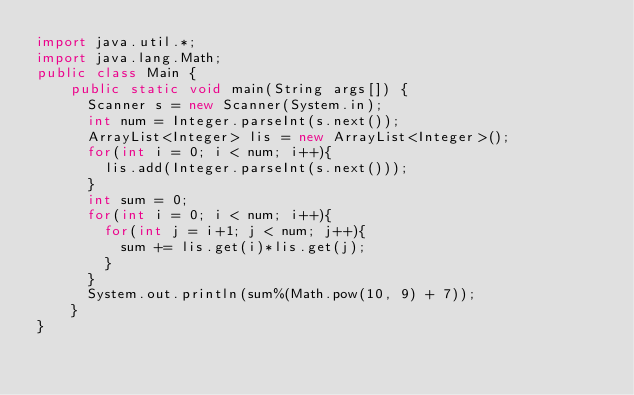<code> <loc_0><loc_0><loc_500><loc_500><_Java_>import java.util.*;
import java.lang.Math;
public class Main {
    public static void main(String args[]) {
      Scanner s = new Scanner(System.in);
      int num = Integer.parseInt(s.next());
      ArrayList<Integer> lis = new ArrayList<Integer>();
      for(int i = 0; i < num; i++){
        lis.add(Integer.parseInt(s.next()));
      }
      int sum = 0;
      for(int i = 0; i < num; i++){
        for(int j = i+1; j < num; j++){
          sum += lis.get(i)*lis.get(j);
        }
      }
      System.out.println(sum%(Math.pow(10, 9) + 7));
    }
}</code> 